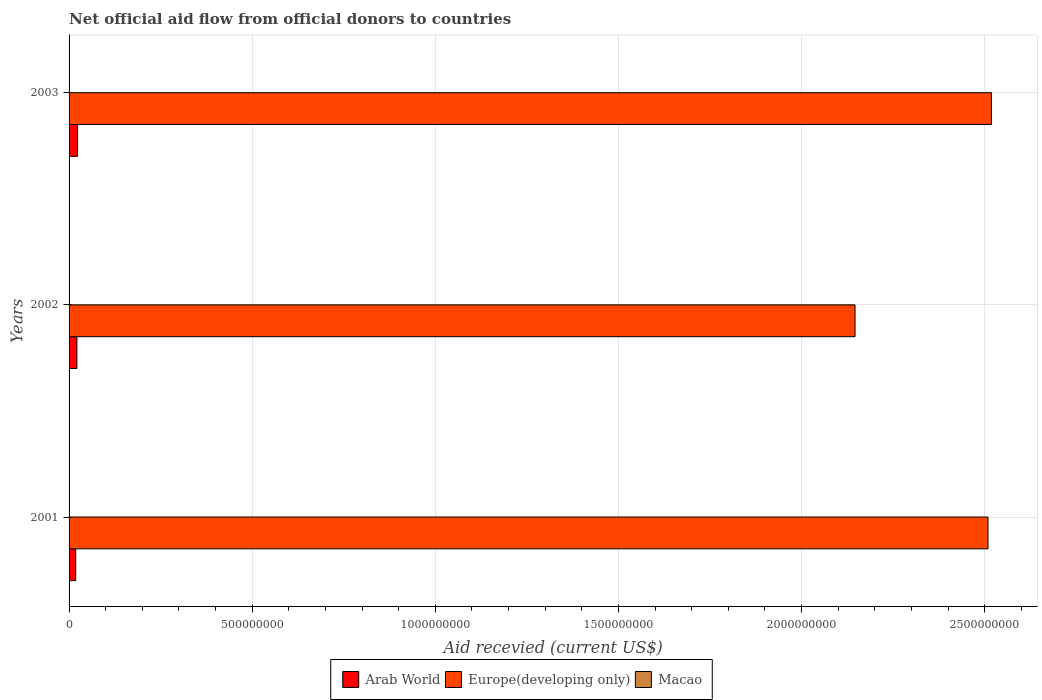How many different coloured bars are there?
Offer a very short reply. 3. Are the number of bars on each tick of the Y-axis equal?
Offer a terse response. Yes. How many bars are there on the 1st tick from the top?
Keep it short and to the point. 3. How many bars are there on the 2nd tick from the bottom?
Your answer should be compact. 3. What is the label of the 3rd group of bars from the top?
Make the answer very short. 2001. What is the total aid received in Europe(developing only) in 2003?
Offer a very short reply. 2.52e+09. Across all years, what is the maximum total aid received in Macao?
Your answer should be very brief. 9.80e+05. What is the total total aid received in Europe(developing only) in the graph?
Provide a succinct answer. 7.17e+09. What is the difference between the total aid received in Europe(developing only) in 2001 and that in 2003?
Keep it short and to the point. -9.21e+06. What is the difference between the total aid received in Arab World in 2001 and the total aid received in Europe(developing only) in 2002?
Your answer should be very brief. -2.13e+09. What is the average total aid received in Europe(developing only) per year?
Offer a very short reply. 2.39e+09. In the year 2003, what is the difference between the total aid received in Macao and total aid received in Europe(developing only)?
Keep it short and to the point. -2.52e+09. In how many years, is the total aid received in Macao greater than 1100000000 US$?
Offer a very short reply. 0. What is the ratio of the total aid received in Macao in 2001 to that in 2002?
Provide a succinct answer. 0.54. Is the total aid received in Europe(developing only) in 2002 less than that in 2003?
Offer a very short reply. Yes. Is the difference between the total aid received in Macao in 2001 and 2003 greater than the difference between the total aid received in Europe(developing only) in 2001 and 2003?
Your answer should be very brief. Yes. What is the difference between the highest and the second highest total aid received in Arab World?
Your response must be concise. 1.81e+06. What is the difference between the highest and the lowest total aid received in Macao?
Ensure brevity in your answer.  8.50e+05. In how many years, is the total aid received in Macao greater than the average total aid received in Macao taken over all years?
Provide a short and direct response. 1. Is the sum of the total aid received in Arab World in 2001 and 2002 greater than the maximum total aid received in Macao across all years?
Your answer should be very brief. Yes. What does the 1st bar from the top in 2001 represents?
Your response must be concise. Macao. What does the 3rd bar from the bottom in 2003 represents?
Offer a terse response. Macao. Is it the case that in every year, the sum of the total aid received in Arab World and total aid received in Macao is greater than the total aid received in Europe(developing only)?
Provide a short and direct response. No. How many years are there in the graph?
Offer a terse response. 3. What is the difference between two consecutive major ticks on the X-axis?
Keep it short and to the point. 5.00e+08. Are the values on the major ticks of X-axis written in scientific E-notation?
Ensure brevity in your answer.  No. Does the graph contain grids?
Your answer should be very brief. Yes. Where does the legend appear in the graph?
Offer a terse response. Bottom center. How many legend labels are there?
Your response must be concise. 3. What is the title of the graph?
Provide a short and direct response. Net official aid flow from official donors to countries. What is the label or title of the X-axis?
Give a very brief answer. Aid recevied (current US$). What is the label or title of the Y-axis?
Give a very brief answer. Years. What is the Aid recevied (current US$) of Arab World in 2001?
Keep it short and to the point. 1.81e+07. What is the Aid recevied (current US$) of Europe(developing only) in 2001?
Make the answer very short. 2.51e+09. What is the Aid recevied (current US$) in Macao in 2001?
Provide a succinct answer. 5.30e+05. What is the Aid recevied (current US$) in Arab World in 2002?
Ensure brevity in your answer.  2.14e+07. What is the Aid recevied (current US$) of Europe(developing only) in 2002?
Make the answer very short. 2.15e+09. What is the Aid recevied (current US$) of Macao in 2002?
Provide a succinct answer. 9.80e+05. What is the Aid recevied (current US$) of Arab World in 2003?
Your response must be concise. 2.32e+07. What is the Aid recevied (current US$) in Europe(developing only) in 2003?
Ensure brevity in your answer.  2.52e+09. Across all years, what is the maximum Aid recevied (current US$) in Arab World?
Provide a short and direct response. 2.32e+07. Across all years, what is the maximum Aid recevied (current US$) in Europe(developing only)?
Make the answer very short. 2.52e+09. Across all years, what is the maximum Aid recevied (current US$) in Macao?
Your response must be concise. 9.80e+05. Across all years, what is the minimum Aid recevied (current US$) of Arab World?
Offer a terse response. 1.81e+07. Across all years, what is the minimum Aid recevied (current US$) in Europe(developing only)?
Make the answer very short. 2.15e+09. What is the total Aid recevied (current US$) in Arab World in the graph?
Your answer should be compact. 6.28e+07. What is the total Aid recevied (current US$) in Europe(developing only) in the graph?
Give a very brief answer. 7.17e+09. What is the total Aid recevied (current US$) of Macao in the graph?
Make the answer very short. 1.64e+06. What is the difference between the Aid recevied (current US$) of Arab World in 2001 and that in 2002?
Give a very brief answer. -3.33e+06. What is the difference between the Aid recevied (current US$) in Europe(developing only) in 2001 and that in 2002?
Keep it short and to the point. 3.63e+08. What is the difference between the Aid recevied (current US$) in Macao in 2001 and that in 2002?
Provide a short and direct response. -4.50e+05. What is the difference between the Aid recevied (current US$) in Arab World in 2001 and that in 2003?
Ensure brevity in your answer.  -5.14e+06. What is the difference between the Aid recevied (current US$) in Europe(developing only) in 2001 and that in 2003?
Keep it short and to the point. -9.21e+06. What is the difference between the Aid recevied (current US$) in Macao in 2001 and that in 2003?
Give a very brief answer. 4.00e+05. What is the difference between the Aid recevied (current US$) of Arab World in 2002 and that in 2003?
Your answer should be very brief. -1.81e+06. What is the difference between the Aid recevied (current US$) of Europe(developing only) in 2002 and that in 2003?
Provide a succinct answer. -3.72e+08. What is the difference between the Aid recevied (current US$) of Macao in 2002 and that in 2003?
Your response must be concise. 8.50e+05. What is the difference between the Aid recevied (current US$) in Arab World in 2001 and the Aid recevied (current US$) in Europe(developing only) in 2002?
Provide a succinct answer. -2.13e+09. What is the difference between the Aid recevied (current US$) in Arab World in 2001 and the Aid recevied (current US$) in Macao in 2002?
Offer a very short reply. 1.71e+07. What is the difference between the Aid recevied (current US$) in Europe(developing only) in 2001 and the Aid recevied (current US$) in Macao in 2002?
Give a very brief answer. 2.51e+09. What is the difference between the Aid recevied (current US$) in Arab World in 2001 and the Aid recevied (current US$) in Europe(developing only) in 2003?
Offer a terse response. -2.50e+09. What is the difference between the Aid recevied (current US$) in Arab World in 2001 and the Aid recevied (current US$) in Macao in 2003?
Provide a short and direct response. 1.80e+07. What is the difference between the Aid recevied (current US$) in Europe(developing only) in 2001 and the Aid recevied (current US$) in Macao in 2003?
Provide a succinct answer. 2.51e+09. What is the difference between the Aid recevied (current US$) in Arab World in 2002 and the Aid recevied (current US$) in Europe(developing only) in 2003?
Offer a very short reply. -2.50e+09. What is the difference between the Aid recevied (current US$) of Arab World in 2002 and the Aid recevied (current US$) of Macao in 2003?
Offer a very short reply. 2.13e+07. What is the difference between the Aid recevied (current US$) of Europe(developing only) in 2002 and the Aid recevied (current US$) of Macao in 2003?
Give a very brief answer. 2.15e+09. What is the average Aid recevied (current US$) of Arab World per year?
Your answer should be very brief. 2.09e+07. What is the average Aid recevied (current US$) in Europe(developing only) per year?
Make the answer very short. 2.39e+09. What is the average Aid recevied (current US$) in Macao per year?
Ensure brevity in your answer.  5.47e+05. In the year 2001, what is the difference between the Aid recevied (current US$) of Arab World and Aid recevied (current US$) of Europe(developing only)?
Provide a succinct answer. -2.49e+09. In the year 2001, what is the difference between the Aid recevied (current US$) in Arab World and Aid recevied (current US$) in Macao?
Give a very brief answer. 1.76e+07. In the year 2001, what is the difference between the Aid recevied (current US$) in Europe(developing only) and Aid recevied (current US$) in Macao?
Your response must be concise. 2.51e+09. In the year 2002, what is the difference between the Aid recevied (current US$) of Arab World and Aid recevied (current US$) of Europe(developing only)?
Give a very brief answer. -2.12e+09. In the year 2002, what is the difference between the Aid recevied (current US$) of Arab World and Aid recevied (current US$) of Macao?
Your response must be concise. 2.05e+07. In the year 2002, what is the difference between the Aid recevied (current US$) of Europe(developing only) and Aid recevied (current US$) of Macao?
Your answer should be very brief. 2.15e+09. In the year 2003, what is the difference between the Aid recevied (current US$) in Arab World and Aid recevied (current US$) in Europe(developing only)?
Offer a terse response. -2.50e+09. In the year 2003, what is the difference between the Aid recevied (current US$) of Arab World and Aid recevied (current US$) of Macao?
Offer a terse response. 2.31e+07. In the year 2003, what is the difference between the Aid recevied (current US$) of Europe(developing only) and Aid recevied (current US$) of Macao?
Your answer should be compact. 2.52e+09. What is the ratio of the Aid recevied (current US$) in Arab World in 2001 to that in 2002?
Give a very brief answer. 0.84. What is the ratio of the Aid recevied (current US$) of Europe(developing only) in 2001 to that in 2002?
Offer a terse response. 1.17. What is the ratio of the Aid recevied (current US$) of Macao in 2001 to that in 2002?
Ensure brevity in your answer.  0.54. What is the ratio of the Aid recevied (current US$) in Arab World in 2001 to that in 2003?
Your answer should be compact. 0.78. What is the ratio of the Aid recevied (current US$) of Europe(developing only) in 2001 to that in 2003?
Your response must be concise. 1. What is the ratio of the Aid recevied (current US$) in Macao in 2001 to that in 2003?
Offer a terse response. 4.08. What is the ratio of the Aid recevied (current US$) in Arab World in 2002 to that in 2003?
Keep it short and to the point. 0.92. What is the ratio of the Aid recevied (current US$) of Europe(developing only) in 2002 to that in 2003?
Provide a succinct answer. 0.85. What is the ratio of the Aid recevied (current US$) of Macao in 2002 to that in 2003?
Your answer should be compact. 7.54. What is the difference between the highest and the second highest Aid recevied (current US$) in Arab World?
Give a very brief answer. 1.81e+06. What is the difference between the highest and the second highest Aid recevied (current US$) of Europe(developing only)?
Your answer should be compact. 9.21e+06. What is the difference between the highest and the lowest Aid recevied (current US$) in Arab World?
Provide a short and direct response. 5.14e+06. What is the difference between the highest and the lowest Aid recevied (current US$) in Europe(developing only)?
Give a very brief answer. 3.72e+08. What is the difference between the highest and the lowest Aid recevied (current US$) of Macao?
Offer a very short reply. 8.50e+05. 